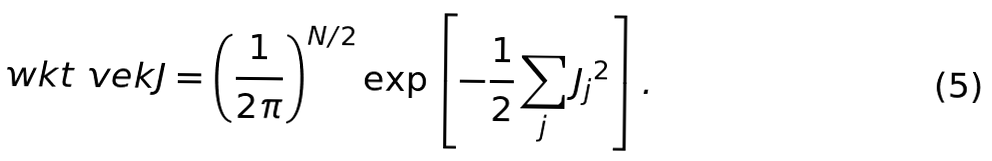Convert formula to latex. <formula><loc_0><loc_0><loc_500><loc_500>\ w k t { \ v e k { J } } = \left ( \frac { 1 } { 2 \pi } \right ) ^ { N / 2 } \exp \left [ - \frac { 1 } { 2 } \sum _ { j } { J _ { j } } ^ { 2 } \right ] .</formula> 